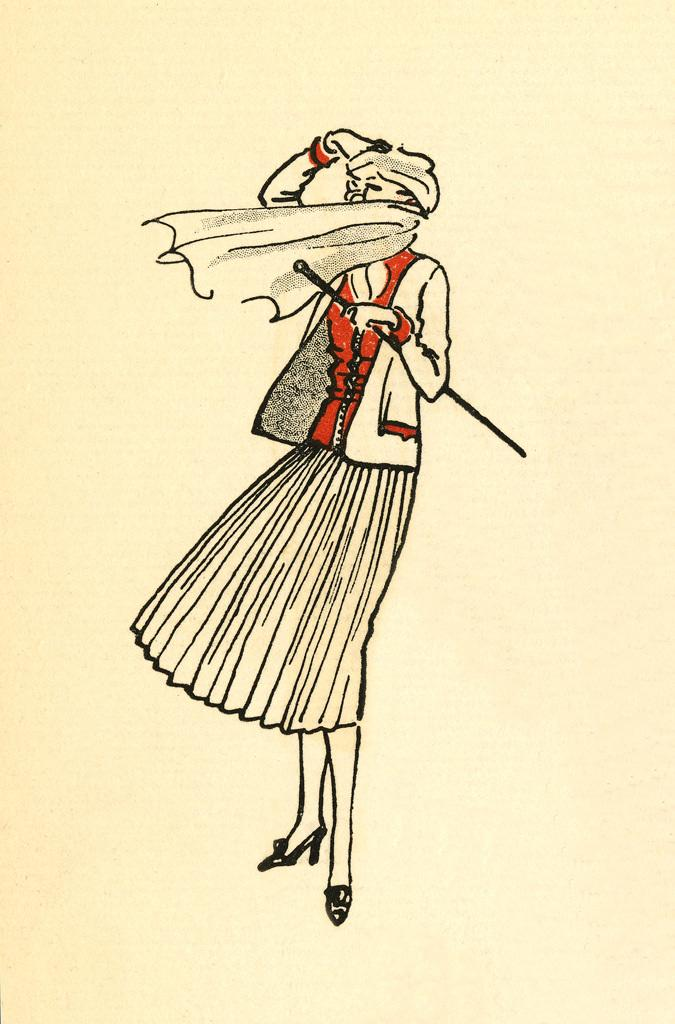What is depicted in the foreground of the image? There is a sketch of a woman in the foreground of the image. What is the woman holding in the sketch? The woman is holding a stick. How is the woman's face covered in the sketch? The woman's face is covered by a scarf. What color is the background of the image? The background of the image is cream-colored. How many roses are in the woman's hand in the image? There are no roses present in the image. The woman is holding a stick, not a rose. 